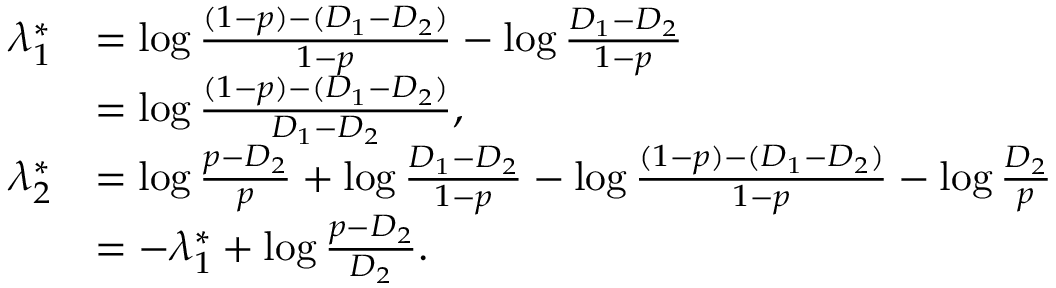Convert formula to latex. <formula><loc_0><loc_0><loc_500><loc_500>\begin{array} { r l } { \lambda _ { 1 } ^ { * } } & { = \log \frac { ( 1 - p ) - ( D _ { 1 } - D _ { 2 } ) } { 1 - p } - \log \frac { D _ { 1 } - D _ { 2 } } { 1 - p } } \\ & { = \log \frac { ( 1 - p ) - ( D _ { 1 } - D _ { 2 } ) } { D _ { 1 } - D _ { 2 } } , } \\ { \lambda _ { 2 } ^ { * } } & { = \log \frac { p - D _ { 2 } } { p } + \log \frac { D _ { 1 } - D _ { 2 } } { 1 - p } - \log \frac { ( 1 - p ) - ( D _ { 1 } - D _ { 2 } ) } { 1 - p } - \log \frac { D _ { 2 } } { p } } \\ & { = - \lambda _ { 1 } ^ { * } + \log \frac { p - D _ { 2 } } { D _ { 2 } } . } \end{array}</formula> 